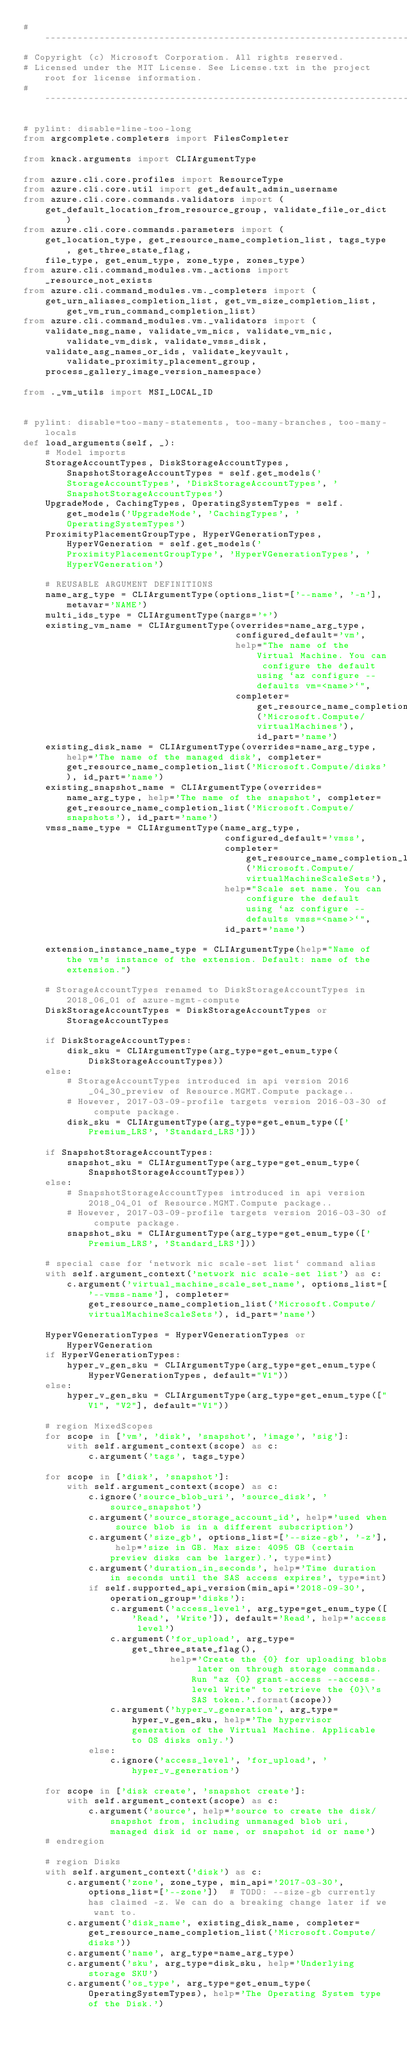<code> <loc_0><loc_0><loc_500><loc_500><_Python_># --------------------------------------------------------------------------------------------
# Copyright (c) Microsoft Corporation. All rights reserved.
# Licensed under the MIT License. See License.txt in the project root for license information.
# --------------------------------------------------------------------------------------------

# pylint: disable=line-too-long
from argcomplete.completers import FilesCompleter

from knack.arguments import CLIArgumentType

from azure.cli.core.profiles import ResourceType
from azure.cli.core.util import get_default_admin_username
from azure.cli.core.commands.validators import (
    get_default_location_from_resource_group, validate_file_or_dict)
from azure.cli.core.commands.parameters import (
    get_location_type, get_resource_name_completion_list, tags_type, get_three_state_flag,
    file_type, get_enum_type, zone_type, zones_type)
from azure.cli.command_modules.vm._actions import _resource_not_exists
from azure.cli.command_modules.vm._completers import (
    get_urn_aliases_completion_list, get_vm_size_completion_list, get_vm_run_command_completion_list)
from azure.cli.command_modules.vm._validators import (
    validate_nsg_name, validate_vm_nics, validate_vm_nic, validate_vm_disk, validate_vmss_disk,
    validate_asg_names_or_ids, validate_keyvault, validate_proximity_placement_group,
    process_gallery_image_version_namespace)

from ._vm_utils import MSI_LOCAL_ID


# pylint: disable=too-many-statements, too-many-branches, too-many-locals
def load_arguments(self, _):
    # Model imports
    StorageAccountTypes, DiskStorageAccountTypes, SnapshotStorageAccountTypes = self.get_models('StorageAccountTypes', 'DiskStorageAccountTypes', 'SnapshotStorageAccountTypes')
    UpgradeMode, CachingTypes, OperatingSystemTypes = self.get_models('UpgradeMode', 'CachingTypes', 'OperatingSystemTypes')
    ProximityPlacementGroupType, HyperVGenerationTypes, HyperVGeneration = self.get_models('ProximityPlacementGroupType', 'HyperVGenerationTypes', 'HyperVGeneration')

    # REUSABLE ARGUMENT DEFINITIONS
    name_arg_type = CLIArgumentType(options_list=['--name', '-n'], metavar='NAME')
    multi_ids_type = CLIArgumentType(nargs='+')
    existing_vm_name = CLIArgumentType(overrides=name_arg_type,
                                       configured_default='vm',
                                       help="The name of the Virtual Machine. You can configure the default using `az configure --defaults vm=<name>`",
                                       completer=get_resource_name_completion_list('Microsoft.Compute/virtualMachines'), id_part='name')
    existing_disk_name = CLIArgumentType(overrides=name_arg_type, help='The name of the managed disk', completer=get_resource_name_completion_list('Microsoft.Compute/disks'), id_part='name')
    existing_snapshot_name = CLIArgumentType(overrides=name_arg_type, help='The name of the snapshot', completer=get_resource_name_completion_list('Microsoft.Compute/snapshots'), id_part='name')
    vmss_name_type = CLIArgumentType(name_arg_type,
                                     configured_default='vmss',
                                     completer=get_resource_name_completion_list('Microsoft.Compute/virtualMachineScaleSets'),
                                     help="Scale set name. You can configure the default using `az configure --defaults vmss=<name>`",
                                     id_part='name')

    extension_instance_name_type = CLIArgumentType(help="Name of the vm's instance of the extension. Default: name of the extension.")

    # StorageAccountTypes renamed to DiskStorageAccountTypes in 2018_06_01 of azure-mgmt-compute
    DiskStorageAccountTypes = DiskStorageAccountTypes or StorageAccountTypes

    if DiskStorageAccountTypes:
        disk_sku = CLIArgumentType(arg_type=get_enum_type(DiskStorageAccountTypes))
    else:
        # StorageAccountTypes introduced in api version 2016_04_30_preview of Resource.MGMT.Compute package..
        # However, 2017-03-09-profile targets version 2016-03-30 of compute package.
        disk_sku = CLIArgumentType(arg_type=get_enum_type(['Premium_LRS', 'Standard_LRS']))

    if SnapshotStorageAccountTypes:
        snapshot_sku = CLIArgumentType(arg_type=get_enum_type(SnapshotStorageAccountTypes))
    else:
        # SnapshotStorageAccountTypes introduced in api version 2018_04_01 of Resource.MGMT.Compute package..
        # However, 2017-03-09-profile targets version 2016-03-30 of compute package.
        snapshot_sku = CLIArgumentType(arg_type=get_enum_type(['Premium_LRS', 'Standard_LRS']))

    # special case for `network nic scale-set list` command alias
    with self.argument_context('network nic scale-set list') as c:
        c.argument('virtual_machine_scale_set_name', options_list=['--vmss-name'], completer=get_resource_name_completion_list('Microsoft.Compute/virtualMachineScaleSets'), id_part='name')

    HyperVGenerationTypes = HyperVGenerationTypes or HyperVGeneration
    if HyperVGenerationTypes:
        hyper_v_gen_sku = CLIArgumentType(arg_type=get_enum_type(HyperVGenerationTypes, default="V1"))
    else:
        hyper_v_gen_sku = CLIArgumentType(arg_type=get_enum_type(["V1", "V2"], default="V1"))

    # region MixedScopes
    for scope in ['vm', 'disk', 'snapshot', 'image', 'sig']:
        with self.argument_context(scope) as c:
            c.argument('tags', tags_type)

    for scope in ['disk', 'snapshot']:
        with self.argument_context(scope) as c:
            c.ignore('source_blob_uri', 'source_disk', 'source_snapshot')
            c.argument('source_storage_account_id', help='used when source blob is in a different subscription')
            c.argument('size_gb', options_list=['--size-gb', '-z'], help='size in GB. Max size: 4095 GB (certain preview disks can be larger).', type=int)
            c.argument('duration_in_seconds', help='Time duration in seconds until the SAS access expires', type=int)
            if self.supported_api_version(min_api='2018-09-30', operation_group='disks'):
                c.argument('access_level', arg_type=get_enum_type(['Read', 'Write']), default='Read', help='access level')
                c.argument('for_upload', arg_type=get_three_state_flag(),
                           help='Create the {0} for uploading blobs later on through storage commands. Run "az {0} grant-access --access-level Write" to retrieve the {0}\'s SAS token.'.format(scope))
                c.argument('hyper_v_generation', arg_type=hyper_v_gen_sku, help='The hypervisor generation of the Virtual Machine. Applicable to OS disks only.')
            else:
                c.ignore('access_level', 'for_upload', 'hyper_v_generation')

    for scope in ['disk create', 'snapshot create']:
        with self.argument_context(scope) as c:
            c.argument('source', help='source to create the disk/snapshot from, including unmanaged blob uri, managed disk id or name, or snapshot id or name')
    # endregion

    # region Disks
    with self.argument_context('disk') as c:
        c.argument('zone', zone_type, min_api='2017-03-30', options_list=['--zone'])  # TODO: --size-gb currently has claimed -z. We can do a breaking change later if we want to.
        c.argument('disk_name', existing_disk_name, completer=get_resource_name_completion_list('Microsoft.Compute/disks'))
        c.argument('name', arg_type=name_arg_type)
        c.argument('sku', arg_type=disk_sku, help='Underlying storage SKU')
        c.argument('os_type', arg_type=get_enum_type(OperatingSystemTypes), help='The Operating System type of the Disk.')</code> 